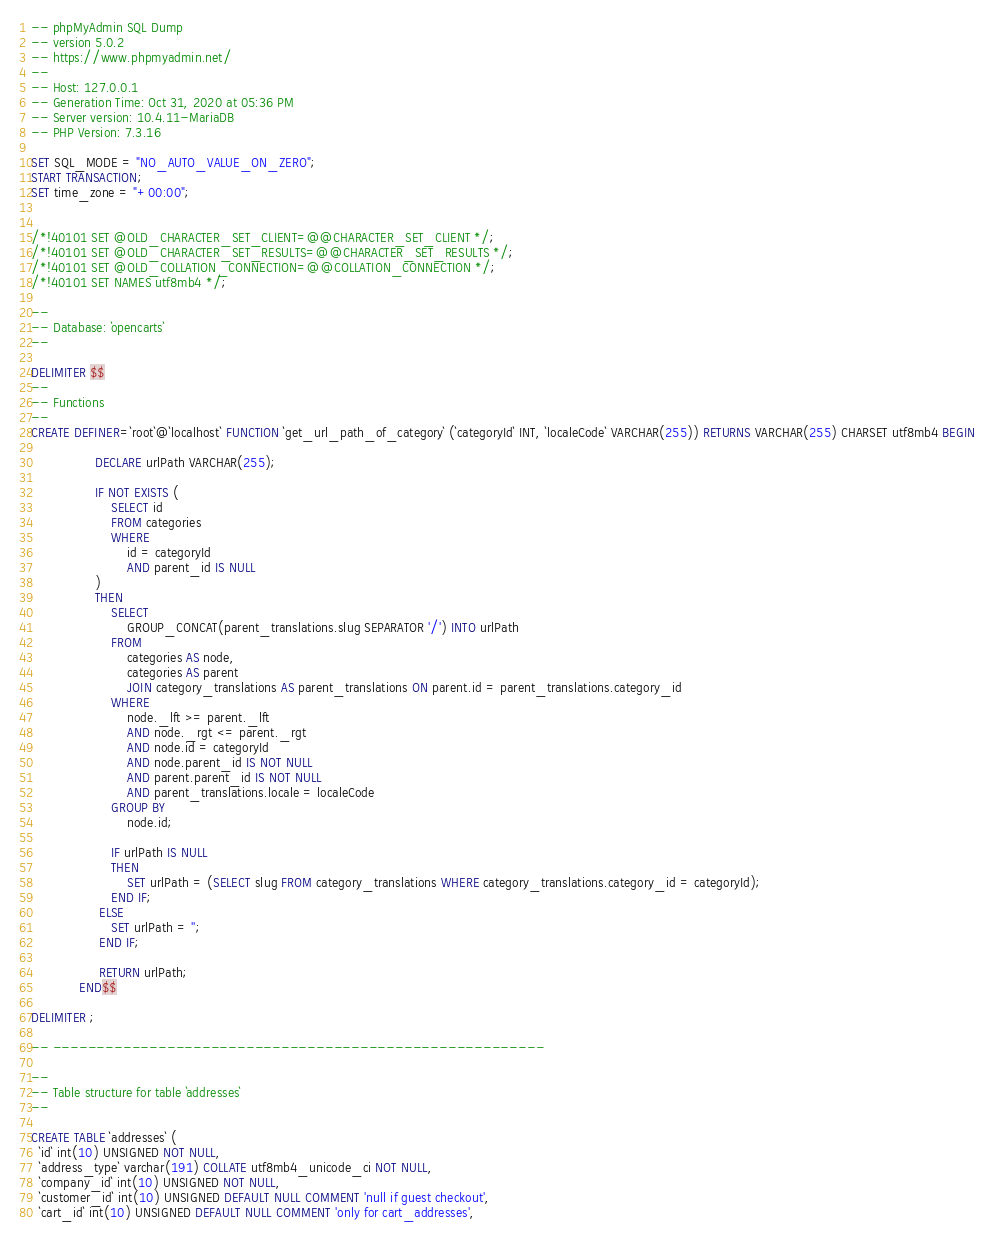<code> <loc_0><loc_0><loc_500><loc_500><_SQL_>-- phpMyAdmin SQL Dump
-- version 5.0.2
-- https://www.phpmyadmin.net/
--
-- Host: 127.0.0.1
-- Generation Time: Oct 31, 2020 at 05:36 PM
-- Server version: 10.4.11-MariaDB
-- PHP Version: 7.3.16

SET SQL_MODE = "NO_AUTO_VALUE_ON_ZERO";
START TRANSACTION;
SET time_zone = "+00:00";


/*!40101 SET @OLD_CHARACTER_SET_CLIENT=@@CHARACTER_SET_CLIENT */;
/*!40101 SET @OLD_CHARACTER_SET_RESULTS=@@CHARACTER_SET_RESULTS */;
/*!40101 SET @OLD_COLLATION_CONNECTION=@@COLLATION_CONNECTION */;
/*!40101 SET NAMES utf8mb4 */;

--
-- Database: `opencarts`
--

DELIMITER $$
--
-- Functions
--
CREATE DEFINER=`root`@`localhost` FUNCTION `get_url_path_of_category` (`categoryId` INT, `localeCode` VARCHAR(255)) RETURNS VARCHAR(255) CHARSET utf8mb4 BEGIN

                DECLARE urlPath VARCHAR(255);

                IF NOT EXISTS (
                    SELECT id
                    FROM categories
                    WHERE
                        id = categoryId
                        AND parent_id IS NULL
                )
                THEN
                    SELECT
                        GROUP_CONCAT(parent_translations.slug SEPARATOR '/') INTO urlPath
                    FROM
                        categories AS node,
                        categories AS parent
                        JOIN category_translations AS parent_translations ON parent.id = parent_translations.category_id
                    WHERE
                        node._lft >= parent._lft
                        AND node._rgt <= parent._rgt
                        AND node.id = categoryId
                        AND node.parent_id IS NOT NULL
                        AND parent.parent_id IS NOT NULL
                        AND parent_translations.locale = localeCode
                    GROUP BY
                        node.id;

                    IF urlPath IS NULL
                    THEN
                        SET urlPath = (SELECT slug FROM category_translations WHERE category_translations.category_id = categoryId);
                    END IF;
                 ELSE
                    SET urlPath = '';
                 END IF;

                 RETURN urlPath;
            END$$

DELIMITER ;

-- --------------------------------------------------------

--
-- Table structure for table `addresses`
--

CREATE TABLE `addresses` (
  `id` int(10) UNSIGNED NOT NULL,
  `address_type` varchar(191) COLLATE utf8mb4_unicode_ci NOT NULL,
  `company_id` int(10) UNSIGNED NOT NULL,
  `customer_id` int(10) UNSIGNED DEFAULT NULL COMMENT 'null if guest checkout',
  `cart_id` int(10) UNSIGNED DEFAULT NULL COMMENT 'only for cart_addresses',</code> 